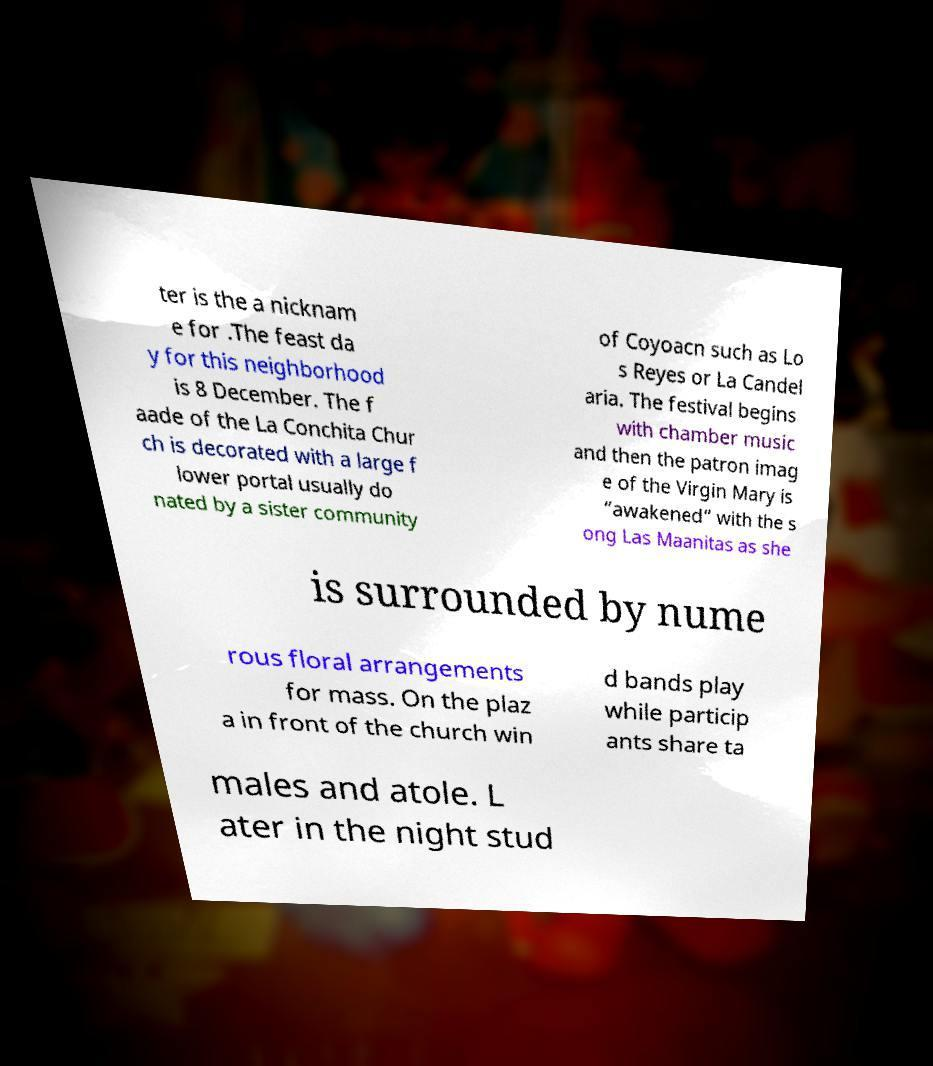Can you accurately transcribe the text from the provided image for me? ter is the a nicknam e for .The feast da y for this neighborhood is 8 December. The f aade of the La Conchita Chur ch is decorated with a large f lower portal usually do nated by a sister community of Coyoacn such as Lo s Reyes or La Candel aria. The festival begins with chamber music and then the patron imag e of the Virgin Mary is “awakened” with the s ong Las Maanitas as she is surrounded by nume rous floral arrangements for mass. On the plaz a in front of the church win d bands play while particip ants share ta males and atole. L ater in the night stud 